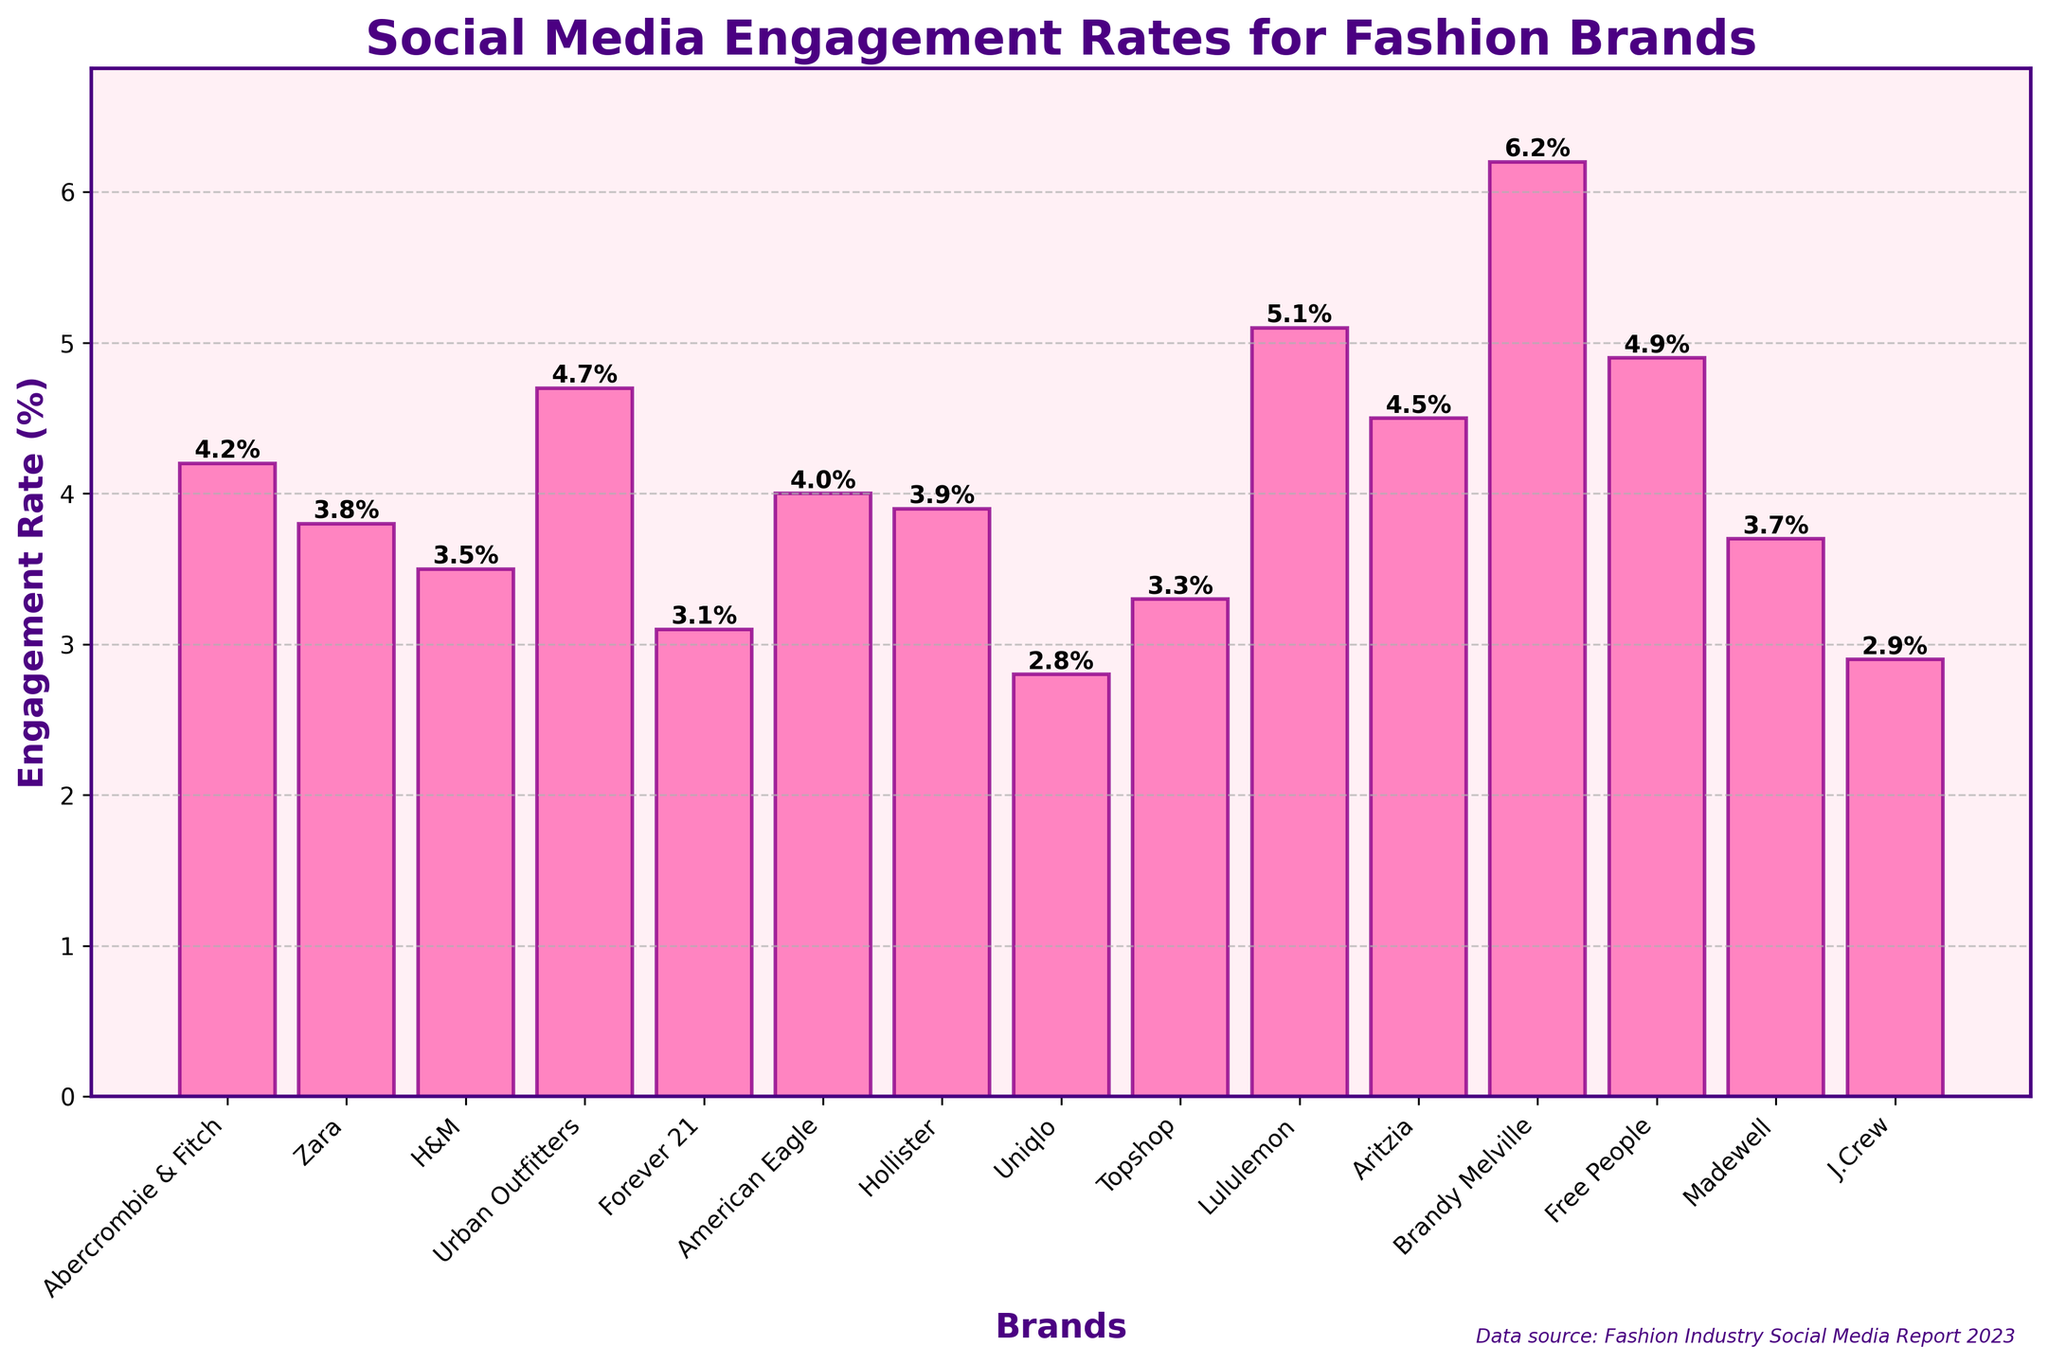What's the engagement rate for Abercrombie & Fitch? The engagement rate for Abercrombie & Fitch is directly shown by the height of the bar corresponding to the brand in the plot. By reading the numerical label on top of the bar, we can see it is 4.2%.
Answer: 4.2% Which fashion brand has the highest engagement rate? To determine the fashion brand with the highest engagement rate, look for the bar that is the tallest in the figure. The tallest bar corresponds to Brandy Melville with a value of 6.2%.
Answer: Brandy Melville How does the engagement rate for Zara compare to that for H&M? To compare the engagement rates of Zara and H&M, look at the heights of the respective bars and their labels. Zara has an engagement rate of 3.8%, while H&M has 3.5%. Zara's engagement rate is slightly higher than H&M's.
Answer: Zara's engagement rate is higher What is the average engagement rate across all the brands? To find the average engagement rate, sum up the engagement rates of all brands and divide by the number of brands. Sum = 4.2 + 3.8 + 3.5 + 4.7 + 3.1 + 4.0 + 3.9 + 2.8 + 3.3 + 5.1 + 4.5 + 6.2 + 4.9 + 3.7 + 2.9 = 60.6. There are 15 brands, so the average ≈ 60.6 / 15 = 4.04%.
Answer: 4.04% Which brands have an engagement rate over 4%? To list the brands with an engagement rate over 4%, look for bars higher than the 4% mark. The brands are Abercrombie & Fitch (4.2%), Urban Outfitters (4.7%), American Eagle (4.0%), Lululemon (5.1%), Aritzia (4.5%), Brandy Melville (6.2%), and Free People (4.9%).
Answer: Abercrombie & Fitch, Urban Outfitters, American Eagle, Lululemon, Aritzia, Brandy Melville, Free People What is the total engagement rate of Uniqlo, Topshop, and J.Crew? To find the total engagement rate of Uniqlo, Topshop, and J.Crew, add their engagement rates together: Uniqlo (2.8%) + Topshop (3.3%) + J.Crew (2.9%) = 2.8 + 3.3 + 2.9 = 9%.
Answer: 9% What is the difference between the highest and lowest engagement rates? The highest engagement rate is 6.2% (Brandy Melville) and the lowest is 2.8% (Uniqlo). The difference is 6.2 - 2.8 = 3.4%.
Answer: 3.4% Do more than half of the brands have an engagement rate below 4%? There are 15 total brands. The brands with engagement rates below 4% are Zara, H&M, Forever 21, Hollister, Uniqlo, Topshop, Madewell, J.Crew (8 brands). Since 8 is more than half of 15, more than half of the brands have an engagement rate below 4%.
Answer: Yes 